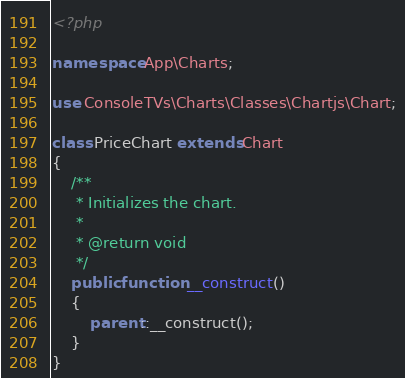Convert code to text. <code><loc_0><loc_0><loc_500><loc_500><_PHP_><?php

namespace App\Charts;

use ConsoleTVs\Charts\Classes\Chartjs\Chart;

class PriceChart extends Chart
{
    /**
     * Initializes the chart.
     *
     * @return void
     */
    public function __construct()
    {
        parent::__construct();
    }
}
</code> 